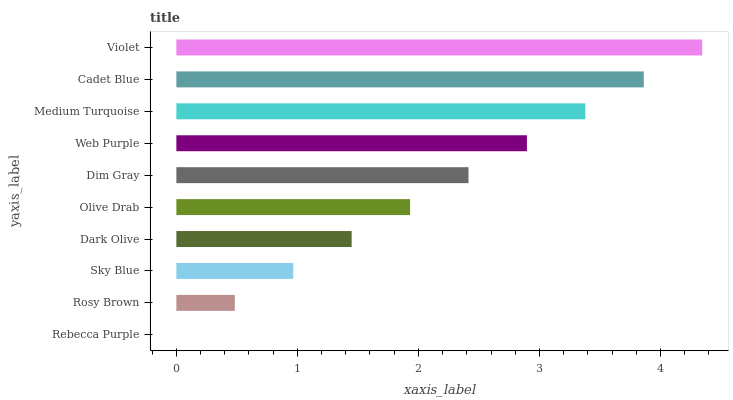Is Rebecca Purple the minimum?
Answer yes or no. Yes. Is Violet the maximum?
Answer yes or no. Yes. Is Rosy Brown the minimum?
Answer yes or no. No. Is Rosy Brown the maximum?
Answer yes or no. No. Is Rosy Brown greater than Rebecca Purple?
Answer yes or no. Yes. Is Rebecca Purple less than Rosy Brown?
Answer yes or no. Yes. Is Rebecca Purple greater than Rosy Brown?
Answer yes or no. No. Is Rosy Brown less than Rebecca Purple?
Answer yes or no. No. Is Dim Gray the high median?
Answer yes or no. Yes. Is Olive Drab the low median?
Answer yes or no. Yes. Is Rosy Brown the high median?
Answer yes or no. No. Is Medium Turquoise the low median?
Answer yes or no. No. 